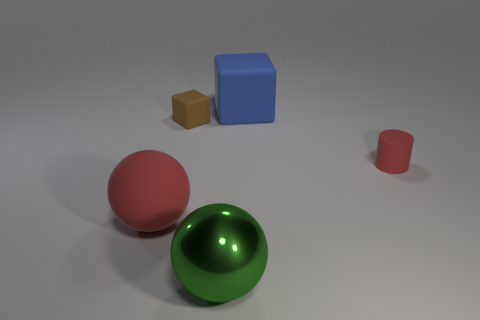What materials seem to be represented by the objects in the image? The objects in the image appear to be digitally rendered with materials that mimic various surface textures. For example, the sphere has a reflective, metallic surface, while the cubes and the cylinder exhibit a matte finish suggestive of plastic or painted surfaces. 